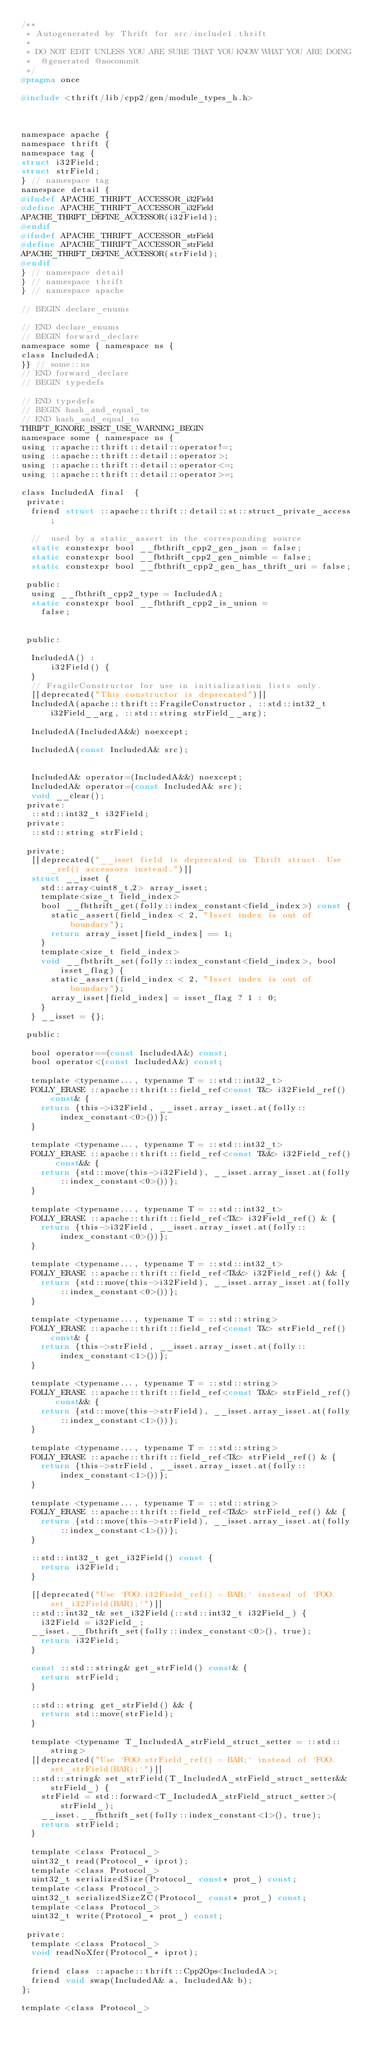<code> <loc_0><loc_0><loc_500><loc_500><_C_>/**
 * Autogenerated by Thrift for src/include1.thrift
 *
 * DO NOT EDIT UNLESS YOU ARE SURE THAT YOU KNOW WHAT YOU ARE DOING
 *  @generated @nocommit
 */
#pragma once

#include <thrift/lib/cpp2/gen/module_types_h.h>



namespace apache {
namespace thrift {
namespace tag {
struct i32Field;
struct strField;
} // namespace tag
namespace detail {
#ifndef APACHE_THRIFT_ACCESSOR_i32Field
#define APACHE_THRIFT_ACCESSOR_i32Field
APACHE_THRIFT_DEFINE_ACCESSOR(i32Field);
#endif
#ifndef APACHE_THRIFT_ACCESSOR_strField
#define APACHE_THRIFT_ACCESSOR_strField
APACHE_THRIFT_DEFINE_ACCESSOR(strField);
#endif
} // namespace detail
} // namespace thrift
} // namespace apache

// BEGIN declare_enums

// END declare_enums
// BEGIN forward_declare
namespace some { namespace ns {
class IncludedA;
}} // some::ns
// END forward_declare
// BEGIN typedefs

// END typedefs
// BEGIN hash_and_equal_to
// END hash_and_equal_to
THRIFT_IGNORE_ISSET_USE_WARNING_BEGIN
namespace some { namespace ns {
using ::apache::thrift::detail::operator!=;
using ::apache::thrift::detail::operator>;
using ::apache::thrift::detail::operator<=;
using ::apache::thrift::detail::operator>=;

class IncludedA final  {
 private:
  friend struct ::apache::thrift::detail::st::struct_private_access;

  //  used by a static_assert in the corresponding source
  static constexpr bool __fbthrift_cpp2_gen_json = false;
  static constexpr bool __fbthrift_cpp2_gen_nimble = false;
  static constexpr bool __fbthrift_cpp2_gen_has_thrift_uri = false;

 public:
  using __fbthrift_cpp2_type = IncludedA;
  static constexpr bool __fbthrift_cpp2_is_union =
    false;


 public:

  IncludedA() :
      i32Field() {
  }
  // FragileConstructor for use in initialization lists only.
  [[deprecated("This constructor is deprecated")]]
  IncludedA(apache::thrift::FragileConstructor, ::std::int32_t i32Field__arg, ::std::string strField__arg);

  IncludedA(IncludedA&&) noexcept;

  IncludedA(const IncludedA& src);


  IncludedA& operator=(IncludedA&&) noexcept;
  IncludedA& operator=(const IncludedA& src);
  void __clear();
 private:
  ::std::int32_t i32Field;
 private:
  ::std::string strField;

 private:
  [[deprecated("__isset field is deprecated in Thrift struct. Use _ref() accessors instead.")]]
  struct __isset {
    std::array<uint8_t,2> array_isset;
    template<size_t field_index>
    bool __fbthrift_get(folly::index_constant<field_index>) const {
      static_assert(field_index < 2, "Isset index is out of boundary");
      return array_isset[field_index] == 1;
    }
    template<size_t field_index>
    void __fbthrift_set(folly::index_constant<field_index>, bool isset_flag) {
      static_assert(field_index < 2, "Isset index is out of boundary");
      array_isset[field_index] = isset_flag ? 1 : 0;
    }
  } __isset = {};

 public:

  bool operator==(const IncludedA&) const;
  bool operator<(const IncludedA&) const;

  template <typename..., typename T = ::std::int32_t>
  FOLLY_ERASE ::apache::thrift::field_ref<const T&> i32Field_ref() const& {
    return {this->i32Field, __isset.array_isset.at(folly::index_constant<0>())};
  }

  template <typename..., typename T = ::std::int32_t>
  FOLLY_ERASE ::apache::thrift::field_ref<const T&&> i32Field_ref() const&& {
    return {std::move(this->i32Field), __isset.array_isset.at(folly::index_constant<0>())};
  }

  template <typename..., typename T = ::std::int32_t>
  FOLLY_ERASE ::apache::thrift::field_ref<T&> i32Field_ref() & {
    return {this->i32Field, __isset.array_isset.at(folly::index_constant<0>())};
  }

  template <typename..., typename T = ::std::int32_t>
  FOLLY_ERASE ::apache::thrift::field_ref<T&&> i32Field_ref() && {
    return {std::move(this->i32Field), __isset.array_isset.at(folly::index_constant<0>())};
  }

  template <typename..., typename T = ::std::string>
  FOLLY_ERASE ::apache::thrift::field_ref<const T&> strField_ref() const& {
    return {this->strField, __isset.array_isset.at(folly::index_constant<1>())};
  }

  template <typename..., typename T = ::std::string>
  FOLLY_ERASE ::apache::thrift::field_ref<const T&&> strField_ref() const&& {
    return {std::move(this->strField), __isset.array_isset.at(folly::index_constant<1>())};
  }

  template <typename..., typename T = ::std::string>
  FOLLY_ERASE ::apache::thrift::field_ref<T&> strField_ref() & {
    return {this->strField, __isset.array_isset.at(folly::index_constant<1>())};
  }

  template <typename..., typename T = ::std::string>
  FOLLY_ERASE ::apache::thrift::field_ref<T&&> strField_ref() && {
    return {std::move(this->strField), __isset.array_isset.at(folly::index_constant<1>())};
  }

  ::std::int32_t get_i32Field() const {
    return i32Field;
  }

  [[deprecated("Use `FOO.i32Field_ref() = BAR;` instead of `FOO.set_i32Field(BAR);`")]]
  ::std::int32_t& set_i32Field(::std::int32_t i32Field_) {
    i32Field = i32Field_;
  __isset.__fbthrift_set(folly::index_constant<0>(), true);
    return i32Field;
  }

  const ::std::string& get_strField() const& {
    return strField;
  }

  ::std::string get_strField() && {
    return std::move(strField);
  }

  template <typename T_IncludedA_strField_struct_setter = ::std::string>
  [[deprecated("Use `FOO.strField_ref() = BAR;` instead of `FOO.set_strField(BAR);`")]]
  ::std::string& set_strField(T_IncludedA_strField_struct_setter&& strField_) {
    strField = std::forward<T_IncludedA_strField_struct_setter>(strField_);
    __isset.__fbthrift_set(folly::index_constant<1>(), true);
    return strField;
  }

  template <class Protocol_>
  uint32_t read(Protocol_* iprot);
  template <class Protocol_>
  uint32_t serializedSize(Protocol_ const* prot_) const;
  template <class Protocol_>
  uint32_t serializedSizeZC(Protocol_ const* prot_) const;
  template <class Protocol_>
  uint32_t write(Protocol_* prot_) const;

 private:
  template <class Protocol_>
  void readNoXfer(Protocol_* iprot);

  friend class ::apache::thrift::Cpp2Ops<IncludedA>;
  friend void swap(IncludedA& a, IncludedA& b);
};

template <class Protocol_></code> 